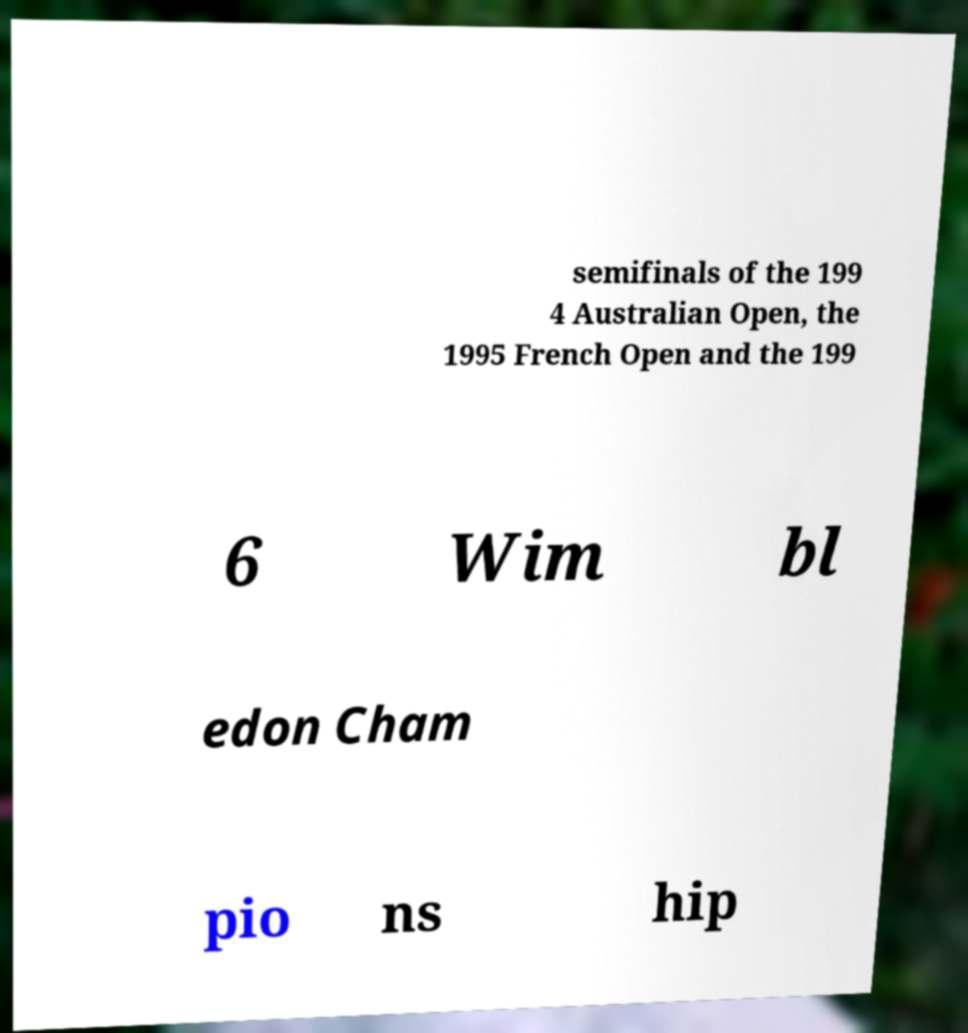Please read and relay the text visible in this image. What does it say? semifinals of the 199 4 Australian Open, the 1995 French Open and the 199 6 Wim bl edon Cham pio ns hip 